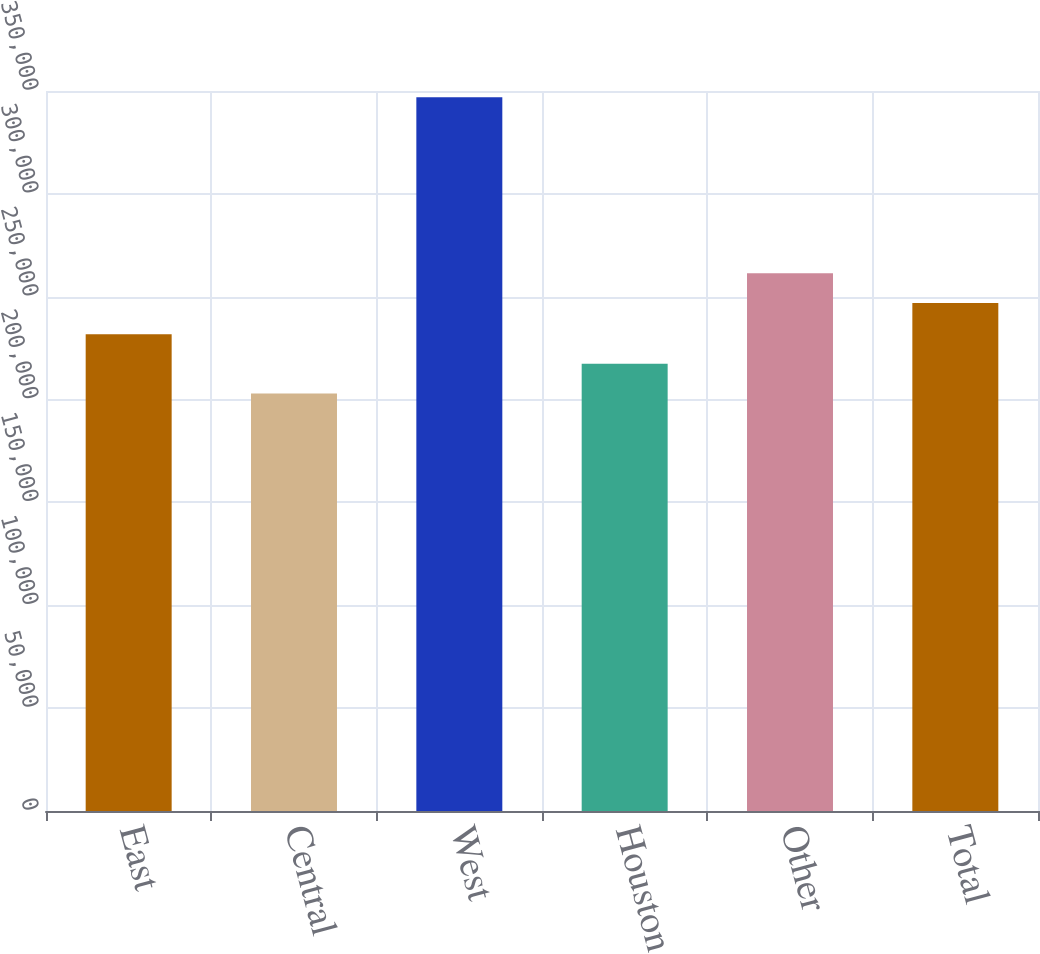Convert chart. <chart><loc_0><loc_0><loc_500><loc_500><bar_chart><fcel>East<fcel>Central<fcel>West<fcel>Houston<fcel>Other<fcel>Total<nl><fcel>231800<fcel>203000<fcel>347000<fcel>217400<fcel>261400<fcel>247000<nl></chart> 